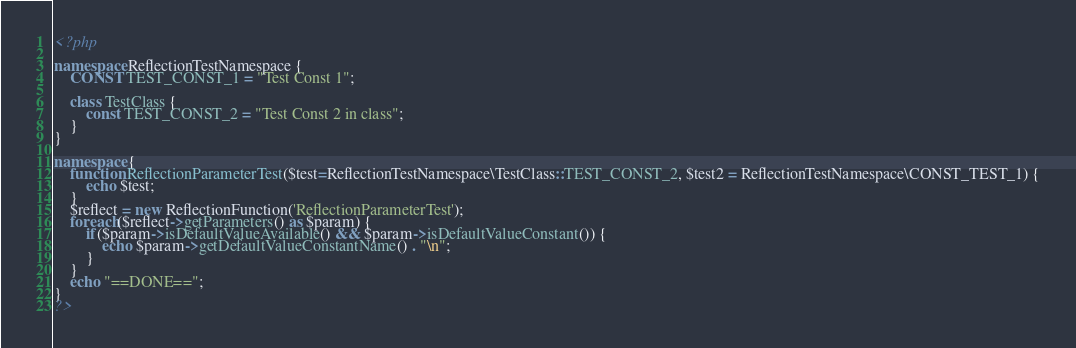<code> <loc_0><loc_0><loc_500><loc_500><_PHP_><?php

namespace ReflectionTestNamespace {
	CONST TEST_CONST_1 = "Test Const 1";

	class TestClass {
		const TEST_CONST_2 = "Test Const 2 in class";
	}
}

namespace {
	function ReflectionParameterTest($test=ReflectionTestNamespace\TestClass::TEST_CONST_2, $test2 = ReflectionTestNamespace\CONST_TEST_1) {
		echo $test;
	}
	$reflect = new ReflectionFunction('ReflectionParameterTest');
	foreach($reflect->getParameters() as $param) {
		if($param->isDefaultValueAvailable() && $param->isDefaultValueConstant()) {
			echo $param->getDefaultValueConstantName() . "\n";
		}
	}
	echo "==DONE==";
}
?>
</code> 